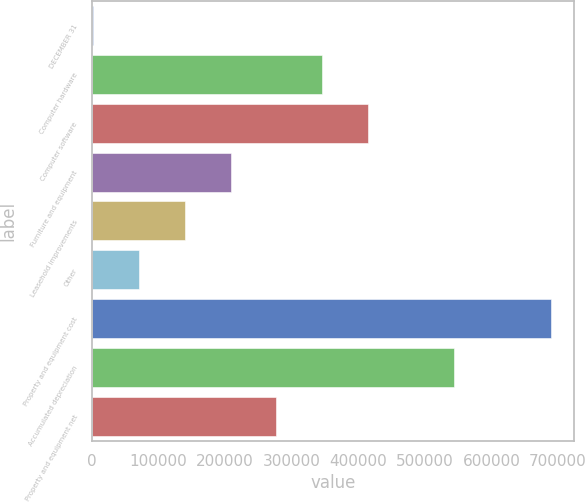<chart> <loc_0><loc_0><loc_500><loc_500><bar_chart><fcel>DECEMBER 31<fcel>Computer hardware<fcel>Computer software<fcel>Furniture and equipment<fcel>Leasehold improvements<fcel>Other<fcel>Property and equipment cost<fcel>Accumulated depreciation<fcel>Property and equipment net<nl><fcel>2008<fcel>345548<fcel>414255<fcel>208132<fcel>139424<fcel>70715.9<fcel>689087<fcel>543388<fcel>276840<nl></chart> 